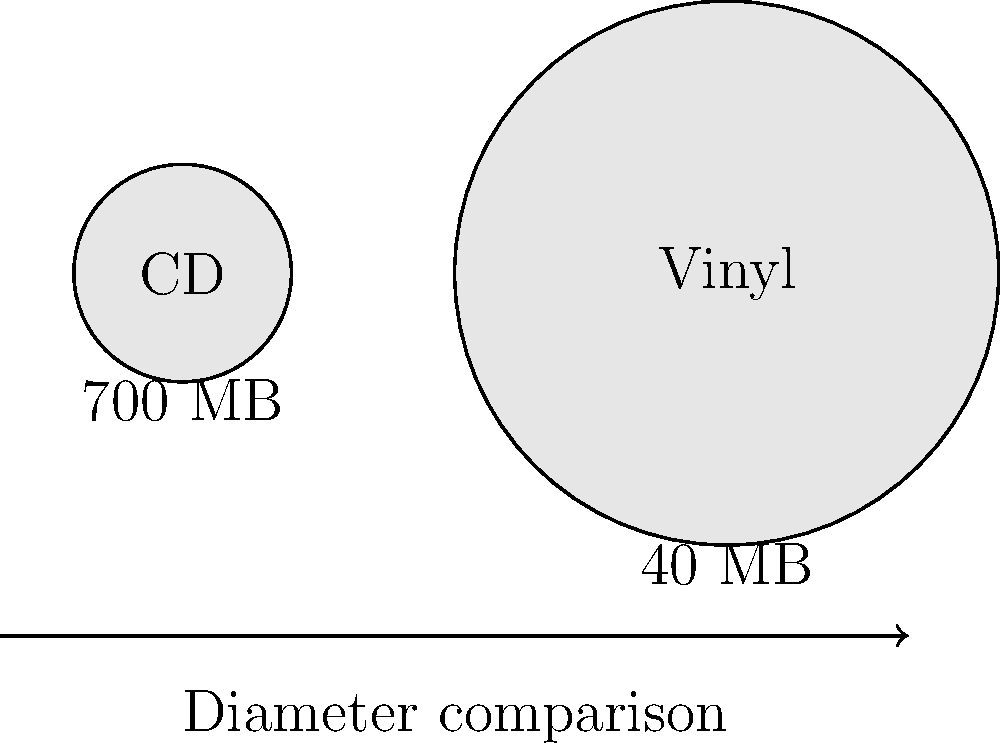Based on the circular diagrams representing a CD and a vinyl record, what is the ratio of the vinyl record's diameter to the CD's diameter, and how many times more storage capacity does the CD have compared to the vinyl record? To solve this question, let's follow these steps:

1. Diameter ratio:
   - The radius of the CD is 6 units
   - The radius of the vinyl record is 15 units
   - Diameter = 2 × radius
   - CD diameter = 2 × 6 = 12 units
   - Vinyl diameter = 2 × 15 = 30 units
   - Ratio = Vinyl diameter : CD diameter = 30 : 12 = 5 : 2

2. Storage capacity comparison:
   - CD capacity = 700 MB
   - Vinyl capacity = 40 MB
   - Difference = 700 MB - 40 MB = 660 MB
   - Ratio = CD capacity : Vinyl capacity = 700 : 40 = 35 : 2

3. How many times more storage:
   $\frac{CD capacity}{Vinyl capacity} = \frac{700}{40} = 17.5$

Therefore, the vinyl record's diameter is 2.5 times larger than the CD's diameter (5:2 ratio), and the CD has 17.5 times more storage capacity than the vinyl record.
Answer: 5:2 diameter ratio; CD has 17.5 times more capacity 